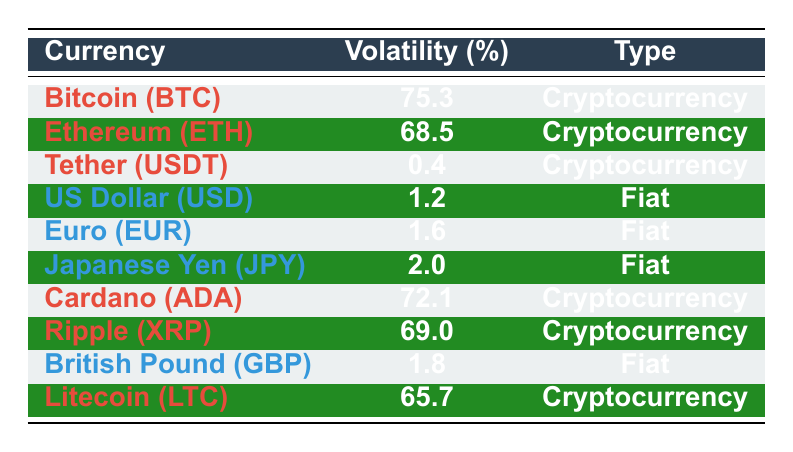What is the volatility percentage of Bitcoin (BTC)? The volatility percentage for Bitcoin (BTC) is listed in the table under the volatility column. It is 75.3.
Answer: 75.3 Which cryptocurrency has the lowest volatility percentage? The table shows that Tether (USDT) has the lowest volatility percentage at 0.4.
Answer: 0.4 What is the average volatility percentage of fiat currencies listed in the table? The fiat currencies and their volatility percentages are: US Dollar (1.2), Euro (1.6), Japanese Yen (2.0), and British Pound (1.8). Adding these gives 1.2 + 1.6 + 2.0 + 1.8 = 6.6. There are 4 fiat currencies, so the average is 6.6 / 4 = 1.65.
Answer: 1.65 Is the volatility percentage of Cardano (ADA) greater than that of Ethereum (ETH)? Cardano has a volatility of 72.1 and Ethereum has a volatility of 68.5. Since 72.1 is greater than 68.5, the statement is true.
Answer: Yes How many cryptocurrencies have a volatility percentage greater than 70? The cryptocurrencies with greater than 70% volatility are Bitcoin (75.3), Ethereum (68.5), Cardano (72.1), and Ripple (69.0). Therefore, we have three cryptocurrencies: Bitcoin, Cardano, and Ripple.
Answer: 3 What is the difference in volatility percentage between the most volatile cryptocurrency and the least volatile fiat currency? The most volatile cryptocurrency is Bitcoin at 75.3 and the least volatile fiat currency is US Dollar at 1.2. The difference is 75.3 - 1.2 = 74.1.
Answer: 74.1 Are all cryptocurrencies more volatile than fiat currencies in this data? By comparing the volatilities, Bitcoin (75.3), Ethereum (68.5), Cardano (72.1), Ripple (69.0), and Litecoin (65.7) are indeed all higher than the fiat currencies (all under 3). Thus, the statement is true.
Answer: Yes Which currency, traditional or cryptocurrency, shows greater stability based on volatility percentage? By examining the table, all fiat currencies have volatility percentages below 3, indicating greater stability compared to cryptocurrencies where the lowest is 65.7. Therefore, traditional currencies show greater stability.
Answer: Traditional currencies show greater stability 